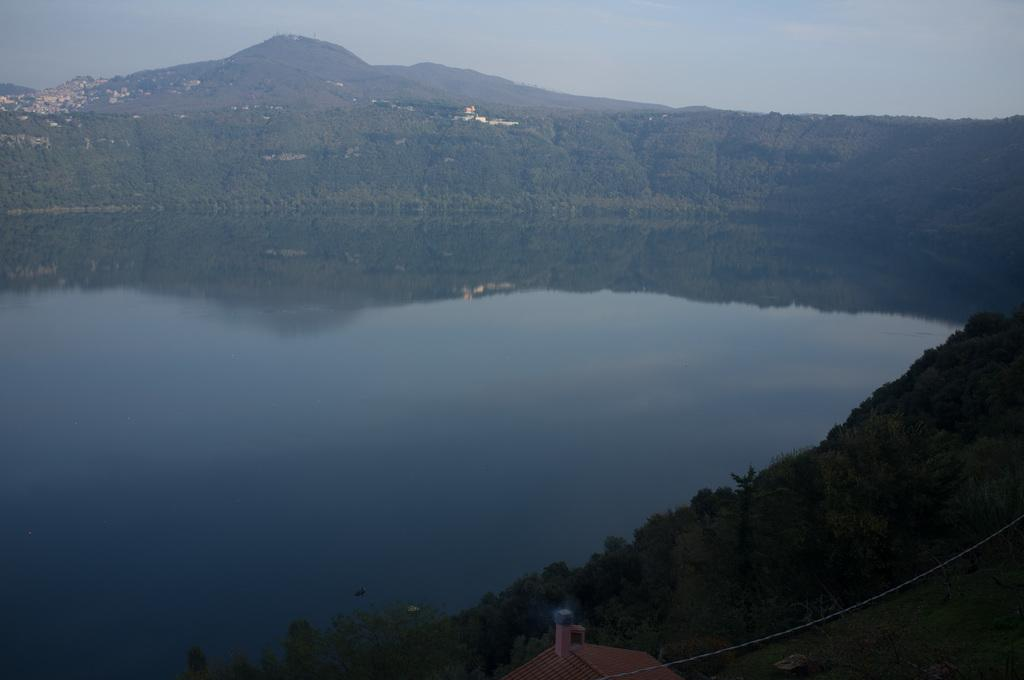What type of natural elements can be seen in the image? There are trees in the image. What type of man-made structures are present in the image? There are buildings in the image. What geographical feature is visible in the image? There is a hill in the image. What body of water can be seen in the image? There is water visible in the image. How would you describe the sky in the image? The sky is blue and cloudy. What type of leather can be seen on the cart in the image? There is no cart or leather present in the image. What type of soda is being served at the water's edge in the image? There is no soda or serving activity present in the image. 